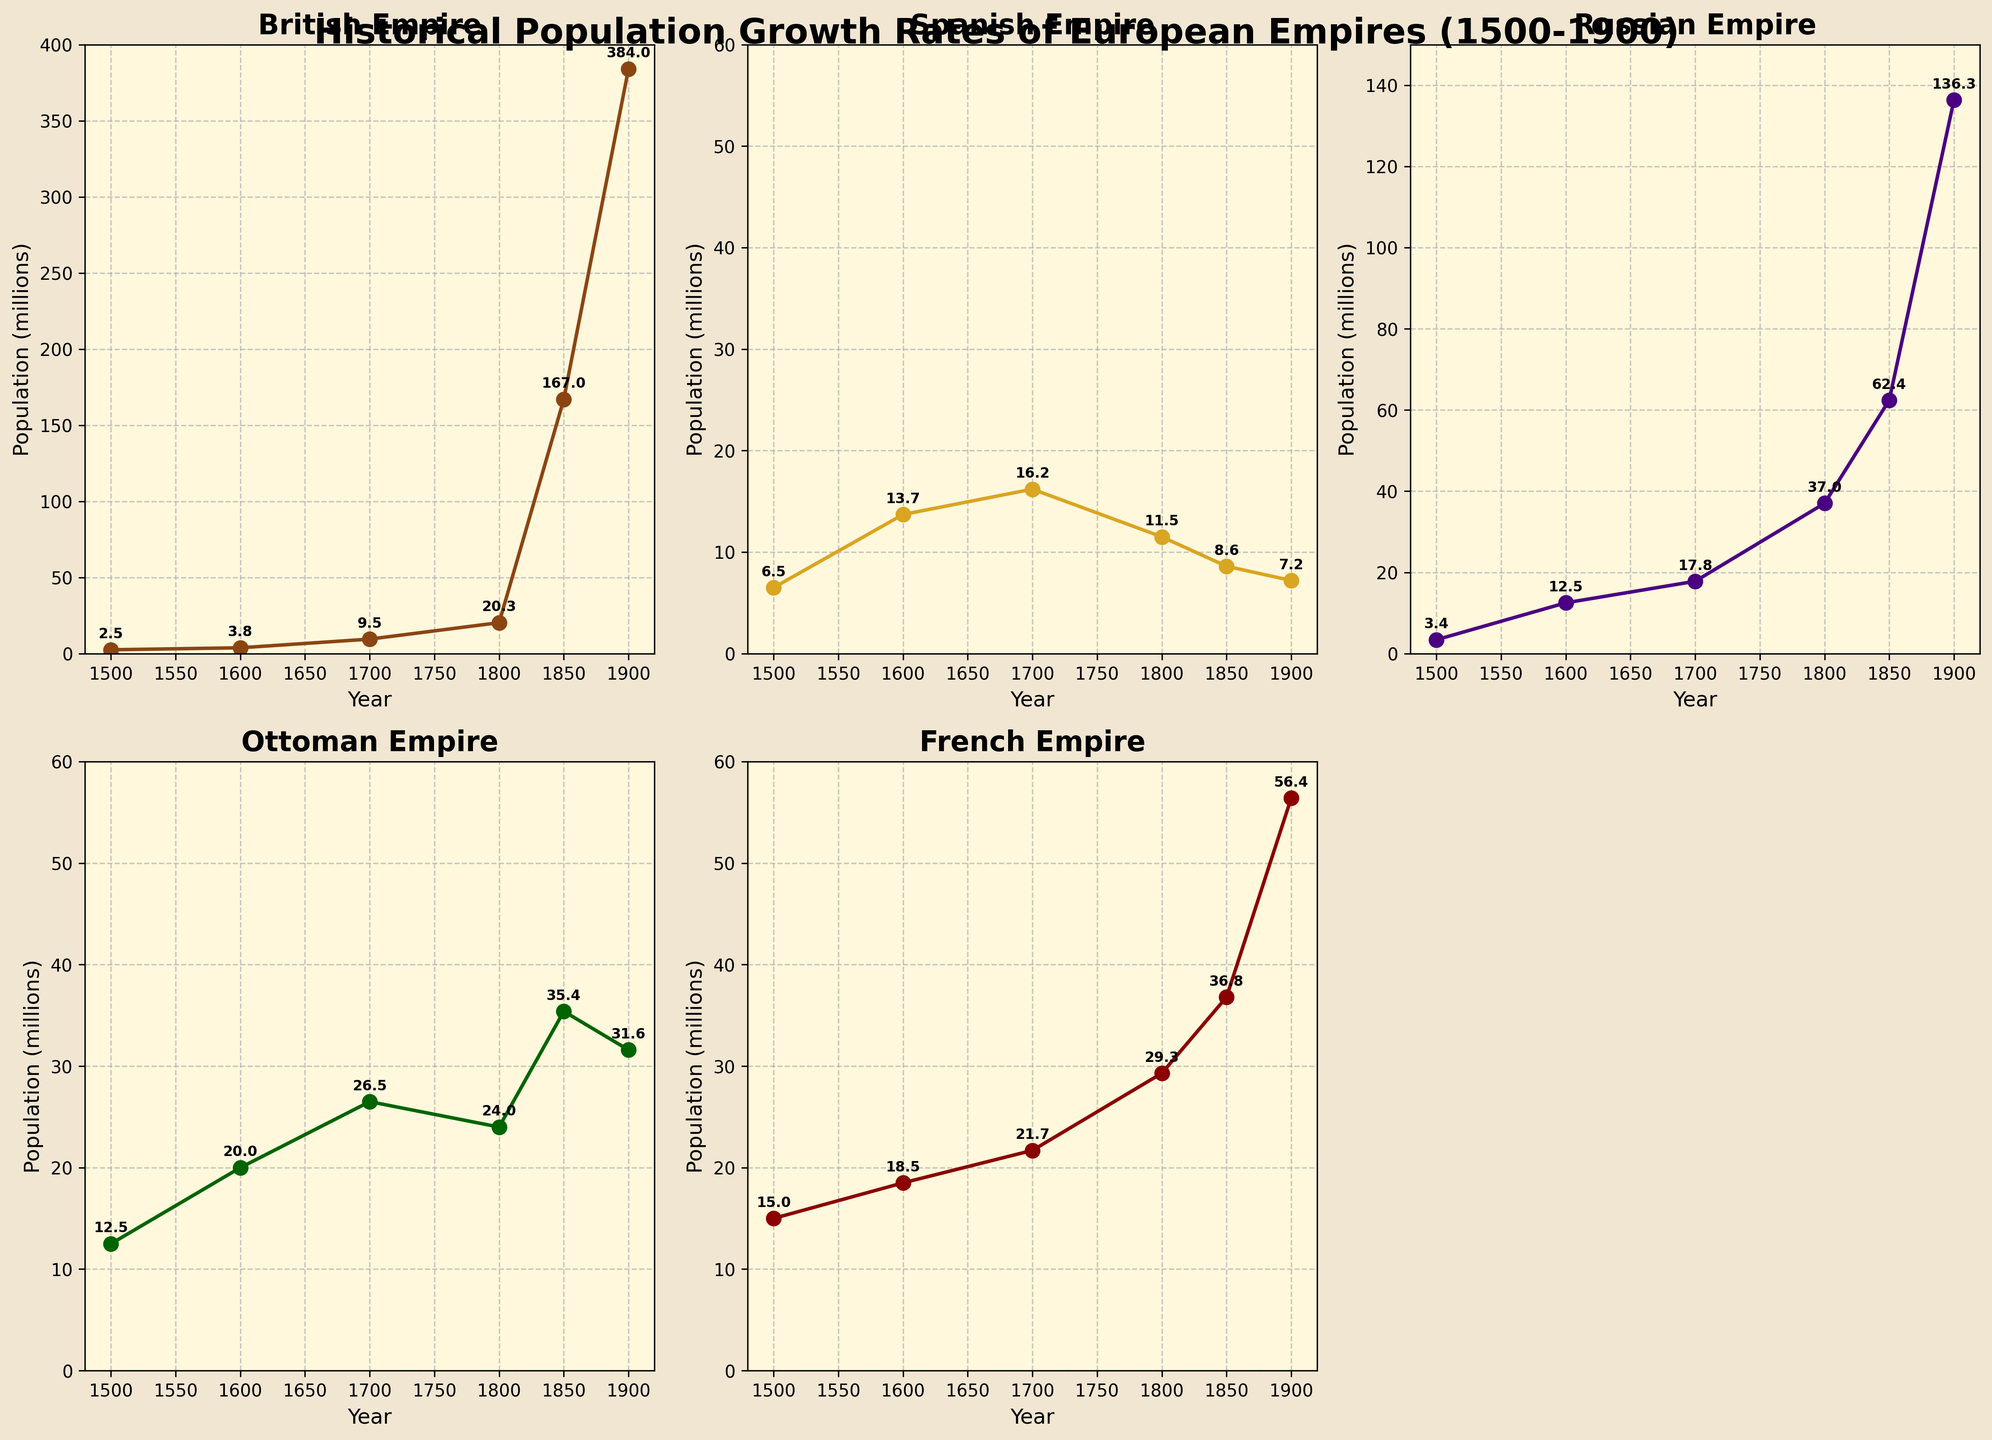What is the title of the figure? The title of the figure is usually found at the top of the plot. In this case, it reads "Historical Population Growth Rates of European Empires (1500-1900)."
Answer: Historical Population Growth Rates of European Empires (1500-1900) What empire had the highest population in 1900? By examining the subplots for 1900, we find that the British Empire has the highest population, marked at 384 million.
Answer: British Empire How many subplots are present in the figure? The figure contains subplots for each empire plus an additional empty subplot. There are 5 filled subplots, making the total number 6, but one is removed, leaving 5 visible.
Answer: 5 Which empire shows a steady decline in population from 1700 to 1900? Upon examining the plots from 1700 to 1900, the Spanish Empire shows a consistent decline in population, from 16.2 million in 1700 to 7.2 million in 1900.
Answer: Spanish Empire Compare the population of the British Empire in 1850 and 1900. What is the difference? The British Empire had a population of 167 million in 1850 and 384 million in 1900. The difference can be calculated as 384 million - 167 million = 217 million.
Answer: 217 million Which empire experienced the largest population growth between 1800 and 1900? Looking at the subplots for 1800 and 1900, the British Empire's population grew from 20.3 million in 1800 to 384 million in 1900, which is an increase of 363.7 million, the largest among the five empires.
Answer: British Empire What is the population trend of the Ottoman Empire from 1600 to 1900? By examining the subplot for the Ottoman Empire from 1600 to 1900, the population increased from 20 million in 1600 to a peak of 35.4 million in 1850, then declined to 31.6 million by 1900.
Answer: Increased then declined Calculate the average population of the French Empire for the recorded years. The populations of the French Empire are 15, 18.5, 21.7, 29.3, 36.8, and 56.4 million for each recorded year. Summing these gives 177.7 million, divided by 6 gives an average of approximately 29.62 million.
Answer: 29.62 million In which year did the Russian Empire surpass the French Empire in population? Comparing the data points for each year, the Russian Empire surpassed the French Empire between 1700 and 1800, at which point the Russian Empire had 37 million compared to the French Empire's 29.3 million.
Answer: 1800 